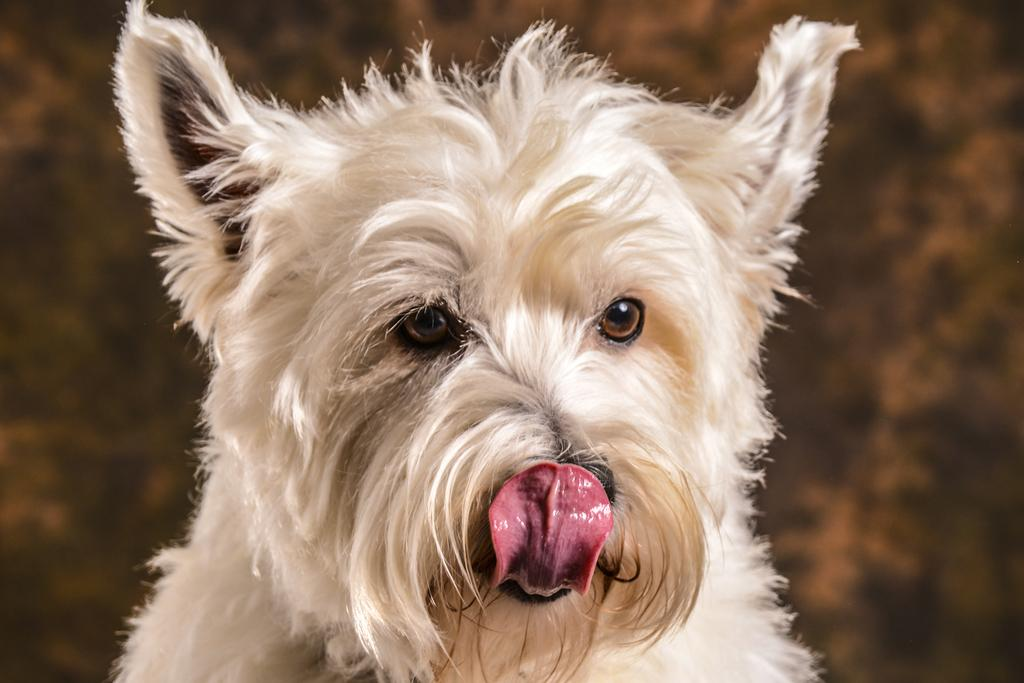What type of animal is in the image? There is a dog in the image. Where is the dog located in the image? The dog is in the middle of the image. What can be seen in the background of the image? There is greenery in the background of the image. What type of drink is on the top of the dog in the image? There is no drink present in the image, and the dog is not holding or wearing anything on its head or top. 